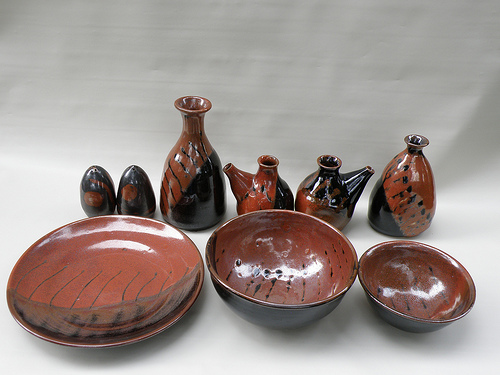Please provide the bounding box coordinate of the region this sentence describes: light shining on the bowl. The bounding box coordinates for the region describing 'light shining on the bowl' are [0.46, 0.62, 0.64, 0.7]. This area highlights where the light is reflecting off of one of the bowls in the image. 